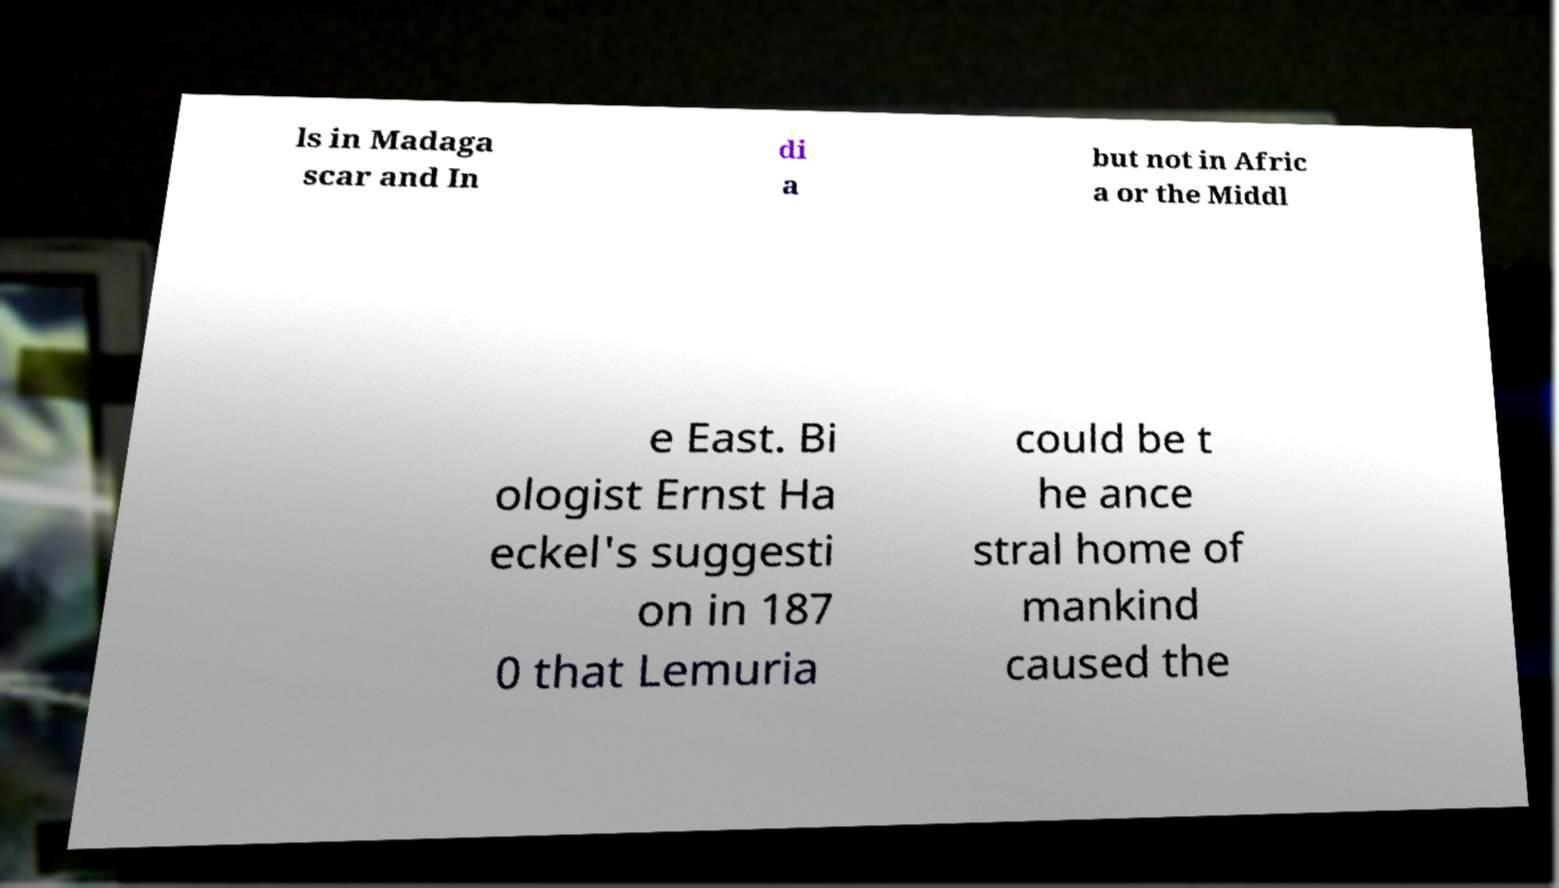Please identify and transcribe the text found in this image. ls in Madaga scar and In di a but not in Afric a or the Middl e East. Bi ologist Ernst Ha eckel's suggesti on in 187 0 that Lemuria could be t he ance stral home of mankind caused the 